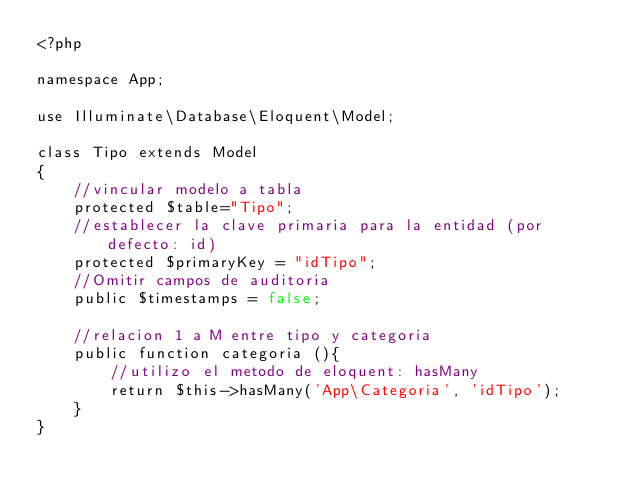<code> <loc_0><loc_0><loc_500><loc_500><_PHP_><?php

namespace App;

use Illuminate\Database\Eloquent\Model;

class Tipo extends Model
{
    //vincular modelo a tabla
    protected $table="Tipo";
    //establecer la clave primaria para la entidad (por defecto: id)
    protected $primaryKey = "idTipo";
    //Omitir campos de auditoria
    public $timestamps = false;

    //relacion 1 a M entre tipo y categoria
    public function categoria (){
        //utilizo el metodo de eloquent: hasMany
        return $this->hasMany('App\Categoria', 'idTipo');
    }
}
</code> 